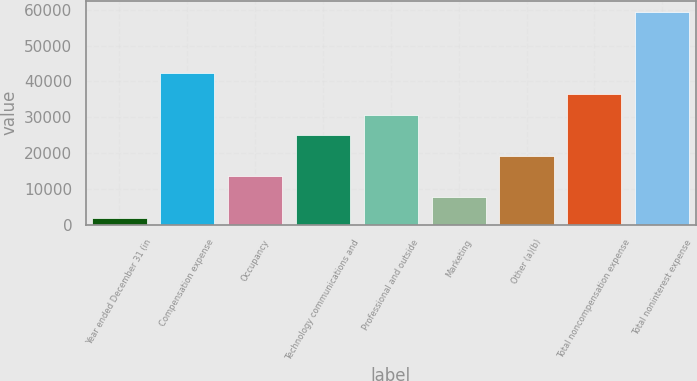<chart> <loc_0><loc_0><loc_500><loc_500><bar_chart><fcel>Year ended December 31 (in<fcel>Compensation expense<fcel>Occupancy<fcel>Technology communications and<fcel>Professional and outside<fcel>Marketing<fcel>Other (a)(b)<fcel>Total noncompensation expense<fcel>Total noninterest expense<nl><fcel>2017<fcel>42265.6<fcel>13516.6<fcel>25016.2<fcel>30766<fcel>7766.8<fcel>19266.4<fcel>36515.8<fcel>59515<nl></chart> 